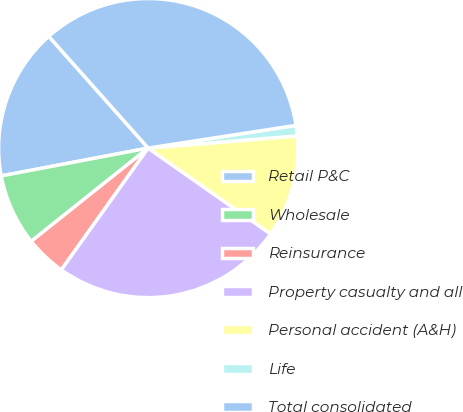<chart> <loc_0><loc_0><loc_500><loc_500><pie_chart><fcel>Retail P&C<fcel>Wholesale<fcel>Reinsurance<fcel>Property casualty and all<fcel>Personal accident (A&H)<fcel>Life<fcel>Total consolidated<nl><fcel>16.41%<fcel>7.73%<fcel>4.43%<fcel>25.13%<fcel>11.03%<fcel>1.13%<fcel>34.14%<nl></chart> 